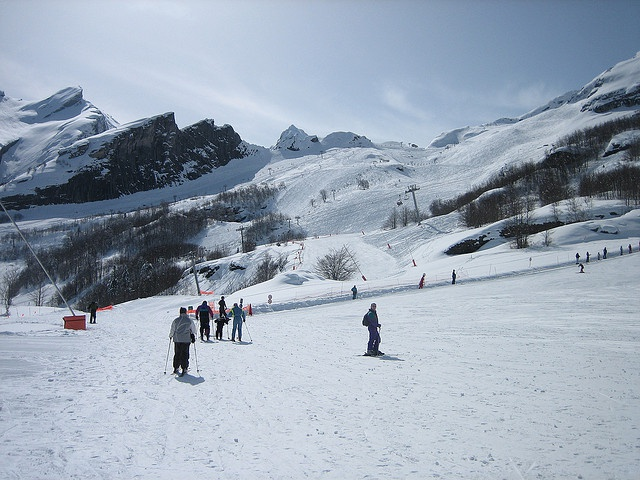Describe the objects in this image and their specific colors. I can see people in darkgray, black, gray, and darkblue tones, people in darkgray, gray, and lightgray tones, people in darkgray, navy, black, gray, and blue tones, people in darkgray, black, navy, and gray tones, and people in darkgray, blue, navy, black, and gray tones in this image. 